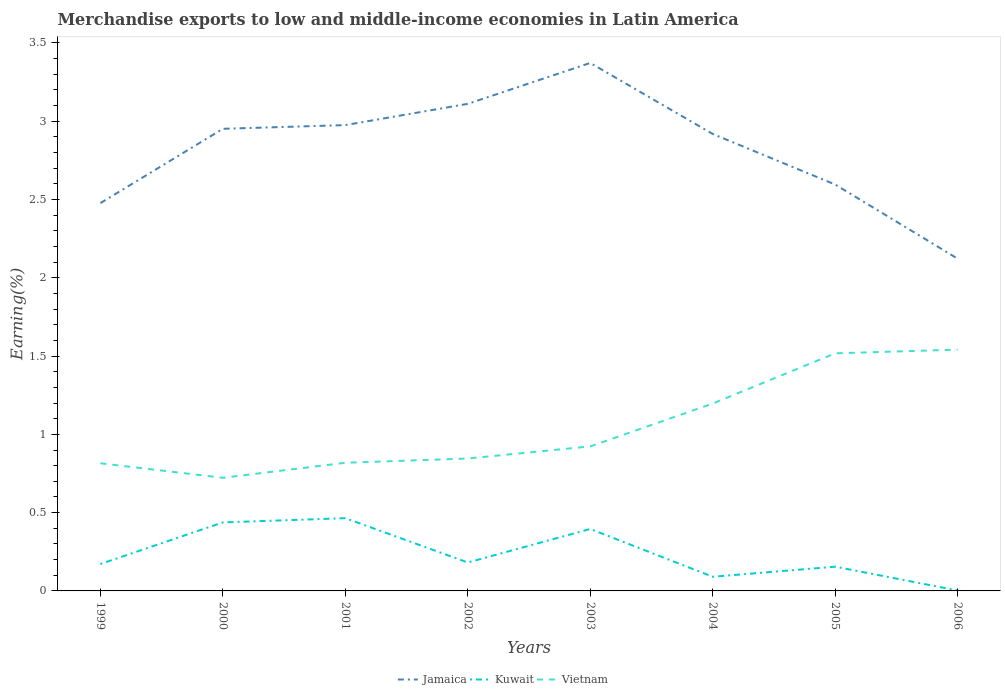Is the number of lines equal to the number of legend labels?
Provide a succinct answer. Yes. Across all years, what is the maximum percentage of amount earned from merchandise exports in Jamaica?
Offer a terse response. 2.12. In which year was the percentage of amount earned from merchandise exports in Kuwait maximum?
Your response must be concise. 2006. What is the total percentage of amount earned from merchandise exports in Kuwait in the graph?
Ensure brevity in your answer.  -0.29. What is the difference between the highest and the second highest percentage of amount earned from merchandise exports in Vietnam?
Ensure brevity in your answer.  0.82. What is the difference between two consecutive major ticks on the Y-axis?
Provide a short and direct response. 0.5. Does the graph contain grids?
Provide a short and direct response. No. How many legend labels are there?
Keep it short and to the point. 3. What is the title of the graph?
Keep it short and to the point. Merchandise exports to low and middle-income economies in Latin America. What is the label or title of the X-axis?
Offer a terse response. Years. What is the label or title of the Y-axis?
Provide a succinct answer. Earning(%). What is the Earning(%) in Jamaica in 1999?
Keep it short and to the point. 2.48. What is the Earning(%) of Kuwait in 1999?
Make the answer very short. 0.17. What is the Earning(%) of Vietnam in 1999?
Offer a very short reply. 0.82. What is the Earning(%) of Jamaica in 2000?
Your answer should be compact. 2.95. What is the Earning(%) of Kuwait in 2000?
Ensure brevity in your answer.  0.44. What is the Earning(%) in Vietnam in 2000?
Give a very brief answer. 0.72. What is the Earning(%) of Jamaica in 2001?
Offer a very short reply. 2.98. What is the Earning(%) of Kuwait in 2001?
Keep it short and to the point. 0.46. What is the Earning(%) in Vietnam in 2001?
Provide a short and direct response. 0.82. What is the Earning(%) in Jamaica in 2002?
Ensure brevity in your answer.  3.11. What is the Earning(%) of Kuwait in 2002?
Provide a succinct answer. 0.18. What is the Earning(%) in Vietnam in 2002?
Give a very brief answer. 0.85. What is the Earning(%) of Jamaica in 2003?
Your answer should be very brief. 3.37. What is the Earning(%) of Kuwait in 2003?
Your response must be concise. 0.4. What is the Earning(%) in Vietnam in 2003?
Offer a terse response. 0.92. What is the Earning(%) of Jamaica in 2004?
Your answer should be very brief. 2.92. What is the Earning(%) in Kuwait in 2004?
Ensure brevity in your answer.  0.09. What is the Earning(%) in Vietnam in 2004?
Your answer should be very brief. 1.2. What is the Earning(%) in Jamaica in 2005?
Offer a very short reply. 2.6. What is the Earning(%) of Kuwait in 2005?
Provide a succinct answer. 0.15. What is the Earning(%) of Vietnam in 2005?
Offer a terse response. 1.52. What is the Earning(%) of Jamaica in 2006?
Give a very brief answer. 2.12. What is the Earning(%) of Kuwait in 2006?
Provide a short and direct response. 0. What is the Earning(%) of Vietnam in 2006?
Provide a succinct answer. 1.54. Across all years, what is the maximum Earning(%) in Jamaica?
Provide a short and direct response. 3.37. Across all years, what is the maximum Earning(%) of Kuwait?
Make the answer very short. 0.46. Across all years, what is the maximum Earning(%) in Vietnam?
Make the answer very short. 1.54. Across all years, what is the minimum Earning(%) of Jamaica?
Your response must be concise. 2.12. Across all years, what is the minimum Earning(%) of Kuwait?
Make the answer very short. 0. Across all years, what is the minimum Earning(%) of Vietnam?
Make the answer very short. 0.72. What is the total Earning(%) in Jamaica in the graph?
Provide a short and direct response. 22.52. What is the total Earning(%) in Kuwait in the graph?
Your answer should be very brief. 1.9. What is the total Earning(%) of Vietnam in the graph?
Your response must be concise. 8.38. What is the difference between the Earning(%) in Jamaica in 1999 and that in 2000?
Provide a succinct answer. -0.47. What is the difference between the Earning(%) in Kuwait in 1999 and that in 2000?
Offer a terse response. -0.27. What is the difference between the Earning(%) of Vietnam in 1999 and that in 2000?
Provide a succinct answer. 0.09. What is the difference between the Earning(%) in Jamaica in 1999 and that in 2001?
Make the answer very short. -0.5. What is the difference between the Earning(%) in Kuwait in 1999 and that in 2001?
Give a very brief answer. -0.29. What is the difference between the Earning(%) in Vietnam in 1999 and that in 2001?
Give a very brief answer. -0. What is the difference between the Earning(%) of Jamaica in 1999 and that in 2002?
Your answer should be compact. -0.63. What is the difference between the Earning(%) in Kuwait in 1999 and that in 2002?
Offer a very short reply. -0.01. What is the difference between the Earning(%) of Vietnam in 1999 and that in 2002?
Ensure brevity in your answer.  -0.03. What is the difference between the Earning(%) in Jamaica in 1999 and that in 2003?
Give a very brief answer. -0.9. What is the difference between the Earning(%) of Kuwait in 1999 and that in 2003?
Provide a short and direct response. -0.22. What is the difference between the Earning(%) in Vietnam in 1999 and that in 2003?
Keep it short and to the point. -0.11. What is the difference between the Earning(%) in Jamaica in 1999 and that in 2004?
Provide a succinct answer. -0.44. What is the difference between the Earning(%) of Kuwait in 1999 and that in 2004?
Offer a terse response. 0.08. What is the difference between the Earning(%) in Vietnam in 1999 and that in 2004?
Provide a short and direct response. -0.38. What is the difference between the Earning(%) in Jamaica in 1999 and that in 2005?
Provide a succinct answer. -0.12. What is the difference between the Earning(%) in Kuwait in 1999 and that in 2005?
Your answer should be compact. 0.02. What is the difference between the Earning(%) of Vietnam in 1999 and that in 2005?
Provide a succinct answer. -0.7. What is the difference between the Earning(%) of Jamaica in 1999 and that in 2006?
Provide a short and direct response. 0.35. What is the difference between the Earning(%) of Kuwait in 1999 and that in 2006?
Your response must be concise. 0.17. What is the difference between the Earning(%) in Vietnam in 1999 and that in 2006?
Provide a short and direct response. -0.73. What is the difference between the Earning(%) in Jamaica in 2000 and that in 2001?
Offer a very short reply. -0.02. What is the difference between the Earning(%) of Kuwait in 2000 and that in 2001?
Provide a succinct answer. -0.03. What is the difference between the Earning(%) in Vietnam in 2000 and that in 2001?
Keep it short and to the point. -0.1. What is the difference between the Earning(%) of Jamaica in 2000 and that in 2002?
Provide a succinct answer. -0.16. What is the difference between the Earning(%) in Kuwait in 2000 and that in 2002?
Provide a succinct answer. 0.26. What is the difference between the Earning(%) of Vietnam in 2000 and that in 2002?
Provide a succinct answer. -0.12. What is the difference between the Earning(%) of Jamaica in 2000 and that in 2003?
Offer a terse response. -0.42. What is the difference between the Earning(%) in Kuwait in 2000 and that in 2003?
Give a very brief answer. 0.04. What is the difference between the Earning(%) of Vietnam in 2000 and that in 2003?
Ensure brevity in your answer.  -0.2. What is the difference between the Earning(%) in Jamaica in 2000 and that in 2004?
Your answer should be very brief. 0.03. What is the difference between the Earning(%) of Kuwait in 2000 and that in 2004?
Ensure brevity in your answer.  0.35. What is the difference between the Earning(%) of Vietnam in 2000 and that in 2004?
Provide a short and direct response. -0.47. What is the difference between the Earning(%) of Jamaica in 2000 and that in 2005?
Your answer should be compact. 0.36. What is the difference between the Earning(%) of Kuwait in 2000 and that in 2005?
Provide a succinct answer. 0.28. What is the difference between the Earning(%) of Vietnam in 2000 and that in 2005?
Your answer should be compact. -0.79. What is the difference between the Earning(%) in Jamaica in 2000 and that in 2006?
Keep it short and to the point. 0.83. What is the difference between the Earning(%) in Kuwait in 2000 and that in 2006?
Make the answer very short. 0.43. What is the difference between the Earning(%) in Vietnam in 2000 and that in 2006?
Offer a terse response. -0.82. What is the difference between the Earning(%) of Jamaica in 2001 and that in 2002?
Provide a short and direct response. -0.14. What is the difference between the Earning(%) in Kuwait in 2001 and that in 2002?
Ensure brevity in your answer.  0.28. What is the difference between the Earning(%) of Vietnam in 2001 and that in 2002?
Ensure brevity in your answer.  -0.03. What is the difference between the Earning(%) in Jamaica in 2001 and that in 2003?
Your response must be concise. -0.4. What is the difference between the Earning(%) in Kuwait in 2001 and that in 2003?
Your answer should be compact. 0.07. What is the difference between the Earning(%) in Vietnam in 2001 and that in 2003?
Your answer should be compact. -0.1. What is the difference between the Earning(%) of Jamaica in 2001 and that in 2004?
Provide a succinct answer. 0.06. What is the difference between the Earning(%) of Kuwait in 2001 and that in 2004?
Offer a terse response. 0.37. What is the difference between the Earning(%) in Vietnam in 2001 and that in 2004?
Your answer should be very brief. -0.38. What is the difference between the Earning(%) of Jamaica in 2001 and that in 2005?
Give a very brief answer. 0.38. What is the difference between the Earning(%) in Kuwait in 2001 and that in 2005?
Keep it short and to the point. 0.31. What is the difference between the Earning(%) of Vietnam in 2001 and that in 2005?
Offer a very short reply. -0.7. What is the difference between the Earning(%) of Jamaica in 2001 and that in 2006?
Give a very brief answer. 0.85. What is the difference between the Earning(%) in Kuwait in 2001 and that in 2006?
Provide a short and direct response. 0.46. What is the difference between the Earning(%) of Vietnam in 2001 and that in 2006?
Your answer should be very brief. -0.72. What is the difference between the Earning(%) in Jamaica in 2002 and that in 2003?
Offer a terse response. -0.26. What is the difference between the Earning(%) in Kuwait in 2002 and that in 2003?
Offer a very short reply. -0.21. What is the difference between the Earning(%) in Vietnam in 2002 and that in 2003?
Your response must be concise. -0.08. What is the difference between the Earning(%) in Jamaica in 2002 and that in 2004?
Your answer should be compact. 0.19. What is the difference between the Earning(%) of Kuwait in 2002 and that in 2004?
Offer a terse response. 0.09. What is the difference between the Earning(%) in Vietnam in 2002 and that in 2004?
Your response must be concise. -0.35. What is the difference between the Earning(%) of Jamaica in 2002 and that in 2005?
Your answer should be compact. 0.52. What is the difference between the Earning(%) in Kuwait in 2002 and that in 2005?
Your response must be concise. 0.03. What is the difference between the Earning(%) in Vietnam in 2002 and that in 2005?
Ensure brevity in your answer.  -0.67. What is the difference between the Earning(%) in Kuwait in 2002 and that in 2006?
Provide a succinct answer. 0.18. What is the difference between the Earning(%) in Vietnam in 2002 and that in 2006?
Offer a very short reply. -0.7. What is the difference between the Earning(%) of Jamaica in 2003 and that in 2004?
Keep it short and to the point. 0.45. What is the difference between the Earning(%) of Kuwait in 2003 and that in 2004?
Your response must be concise. 0.31. What is the difference between the Earning(%) in Vietnam in 2003 and that in 2004?
Your response must be concise. -0.27. What is the difference between the Earning(%) in Jamaica in 2003 and that in 2005?
Make the answer very short. 0.78. What is the difference between the Earning(%) of Kuwait in 2003 and that in 2005?
Ensure brevity in your answer.  0.24. What is the difference between the Earning(%) in Vietnam in 2003 and that in 2005?
Provide a short and direct response. -0.59. What is the difference between the Earning(%) in Jamaica in 2003 and that in 2006?
Your answer should be compact. 1.25. What is the difference between the Earning(%) of Kuwait in 2003 and that in 2006?
Your answer should be very brief. 0.39. What is the difference between the Earning(%) of Vietnam in 2003 and that in 2006?
Make the answer very short. -0.62. What is the difference between the Earning(%) of Jamaica in 2004 and that in 2005?
Provide a short and direct response. 0.32. What is the difference between the Earning(%) in Kuwait in 2004 and that in 2005?
Keep it short and to the point. -0.06. What is the difference between the Earning(%) of Vietnam in 2004 and that in 2005?
Make the answer very short. -0.32. What is the difference between the Earning(%) of Jamaica in 2004 and that in 2006?
Offer a terse response. 0.8. What is the difference between the Earning(%) of Kuwait in 2004 and that in 2006?
Provide a short and direct response. 0.09. What is the difference between the Earning(%) of Vietnam in 2004 and that in 2006?
Your response must be concise. -0.34. What is the difference between the Earning(%) of Jamaica in 2005 and that in 2006?
Your answer should be compact. 0.47. What is the difference between the Earning(%) in Kuwait in 2005 and that in 2006?
Your response must be concise. 0.15. What is the difference between the Earning(%) in Vietnam in 2005 and that in 2006?
Make the answer very short. -0.02. What is the difference between the Earning(%) in Jamaica in 1999 and the Earning(%) in Kuwait in 2000?
Your answer should be very brief. 2.04. What is the difference between the Earning(%) of Jamaica in 1999 and the Earning(%) of Vietnam in 2000?
Give a very brief answer. 1.75. What is the difference between the Earning(%) of Kuwait in 1999 and the Earning(%) of Vietnam in 2000?
Your answer should be compact. -0.55. What is the difference between the Earning(%) of Jamaica in 1999 and the Earning(%) of Kuwait in 2001?
Ensure brevity in your answer.  2.01. What is the difference between the Earning(%) in Jamaica in 1999 and the Earning(%) in Vietnam in 2001?
Your response must be concise. 1.66. What is the difference between the Earning(%) in Kuwait in 1999 and the Earning(%) in Vietnam in 2001?
Make the answer very short. -0.65. What is the difference between the Earning(%) of Jamaica in 1999 and the Earning(%) of Kuwait in 2002?
Offer a very short reply. 2.3. What is the difference between the Earning(%) of Jamaica in 1999 and the Earning(%) of Vietnam in 2002?
Your response must be concise. 1.63. What is the difference between the Earning(%) in Kuwait in 1999 and the Earning(%) in Vietnam in 2002?
Offer a terse response. -0.67. What is the difference between the Earning(%) in Jamaica in 1999 and the Earning(%) in Kuwait in 2003?
Make the answer very short. 2.08. What is the difference between the Earning(%) of Jamaica in 1999 and the Earning(%) of Vietnam in 2003?
Provide a succinct answer. 1.55. What is the difference between the Earning(%) in Kuwait in 1999 and the Earning(%) in Vietnam in 2003?
Keep it short and to the point. -0.75. What is the difference between the Earning(%) in Jamaica in 1999 and the Earning(%) in Kuwait in 2004?
Ensure brevity in your answer.  2.39. What is the difference between the Earning(%) in Jamaica in 1999 and the Earning(%) in Vietnam in 2004?
Make the answer very short. 1.28. What is the difference between the Earning(%) in Kuwait in 1999 and the Earning(%) in Vietnam in 2004?
Make the answer very short. -1.02. What is the difference between the Earning(%) of Jamaica in 1999 and the Earning(%) of Kuwait in 2005?
Offer a very short reply. 2.32. What is the difference between the Earning(%) of Jamaica in 1999 and the Earning(%) of Vietnam in 2005?
Give a very brief answer. 0.96. What is the difference between the Earning(%) in Kuwait in 1999 and the Earning(%) in Vietnam in 2005?
Provide a short and direct response. -1.35. What is the difference between the Earning(%) in Jamaica in 1999 and the Earning(%) in Kuwait in 2006?
Ensure brevity in your answer.  2.47. What is the difference between the Earning(%) of Jamaica in 1999 and the Earning(%) of Vietnam in 2006?
Give a very brief answer. 0.94. What is the difference between the Earning(%) in Kuwait in 1999 and the Earning(%) in Vietnam in 2006?
Give a very brief answer. -1.37. What is the difference between the Earning(%) of Jamaica in 2000 and the Earning(%) of Kuwait in 2001?
Your response must be concise. 2.49. What is the difference between the Earning(%) in Jamaica in 2000 and the Earning(%) in Vietnam in 2001?
Offer a terse response. 2.13. What is the difference between the Earning(%) of Kuwait in 2000 and the Earning(%) of Vietnam in 2001?
Give a very brief answer. -0.38. What is the difference between the Earning(%) in Jamaica in 2000 and the Earning(%) in Kuwait in 2002?
Give a very brief answer. 2.77. What is the difference between the Earning(%) of Jamaica in 2000 and the Earning(%) of Vietnam in 2002?
Offer a terse response. 2.11. What is the difference between the Earning(%) in Kuwait in 2000 and the Earning(%) in Vietnam in 2002?
Ensure brevity in your answer.  -0.41. What is the difference between the Earning(%) in Jamaica in 2000 and the Earning(%) in Kuwait in 2003?
Provide a succinct answer. 2.56. What is the difference between the Earning(%) in Jamaica in 2000 and the Earning(%) in Vietnam in 2003?
Keep it short and to the point. 2.03. What is the difference between the Earning(%) of Kuwait in 2000 and the Earning(%) of Vietnam in 2003?
Give a very brief answer. -0.49. What is the difference between the Earning(%) of Jamaica in 2000 and the Earning(%) of Kuwait in 2004?
Provide a short and direct response. 2.86. What is the difference between the Earning(%) of Jamaica in 2000 and the Earning(%) of Vietnam in 2004?
Your answer should be very brief. 1.75. What is the difference between the Earning(%) of Kuwait in 2000 and the Earning(%) of Vietnam in 2004?
Ensure brevity in your answer.  -0.76. What is the difference between the Earning(%) of Jamaica in 2000 and the Earning(%) of Kuwait in 2005?
Your answer should be compact. 2.8. What is the difference between the Earning(%) of Jamaica in 2000 and the Earning(%) of Vietnam in 2005?
Provide a succinct answer. 1.43. What is the difference between the Earning(%) in Kuwait in 2000 and the Earning(%) in Vietnam in 2005?
Make the answer very short. -1.08. What is the difference between the Earning(%) of Jamaica in 2000 and the Earning(%) of Kuwait in 2006?
Give a very brief answer. 2.95. What is the difference between the Earning(%) of Jamaica in 2000 and the Earning(%) of Vietnam in 2006?
Make the answer very short. 1.41. What is the difference between the Earning(%) of Kuwait in 2000 and the Earning(%) of Vietnam in 2006?
Provide a short and direct response. -1.1. What is the difference between the Earning(%) in Jamaica in 2001 and the Earning(%) in Kuwait in 2002?
Make the answer very short. 2.79. What is the difference between the Earning(%) of Jamaica in 2001 and the Earning(%) of Vietnam in 2002?
Give a very brief answer. 2.13. What is the difference between the Earning(%) of Kuwait in 2001 and the Earning(%) of Vietnam in 2002?
Offer a terse response. -0.38. What is the difference between the Earning(%) of Jamaica in 2001 and the Earning(%) of Kuwait in 2003?
Make the answer very short. 2.58. What is the difference between the Earning(%) of Jamaica in 2001 and the Earning(%) of Vietnam in 2003?
Make the answer very short. 2.05. What is the difference between the Earning(%) of Kuwait in 2001 and the Earning(%) of Vietnam in 2003?
Your answer should be very brief. -0.46. What is the difference between the Earning(%) in Jamaica in 2001 and the Earning(%) in Kuwait in 2004?
Your answer should be very brief. 2.88. What is the difference between the Earning(%) of Jamaica in 2001 and the Earning(%) of Vietnam in 2004?
Your response must be concise. 1.78. What is the difference between the Earning(%) in Kuwait in 2001 and the Earning(%) in Vietnam in 2004?
Ensure brevity in your answer.  -0.73. What is the difference between the Earning(%) of Jamaica in 2001 and the Earning(%) of Kuwait in 2005?
Your response must be concise. 2.82. What is the difference between the Earning(%) in Jamaica in 2001 and the Earning(%) in Vietnam in 2005?
Your answer should be compact. 1.46. What is the difference between the Earning(%) of Kuwait in 2001 and the Earning(%) of Vietnam in 2005?
Your answer should be compact. -1.05. What is the difference between the Earning(%) in Jamaica in 2001 and the Earning(%) in Kuwait in 2006?
Ensure brevity in your answer.  2.97. What is the difference between the Earning(%) in Jamaica in 2001 and the Earning(%) in Vietnam in 2006?
Provide a succinct answer. 1.43. What is the difference between the Earning(%) of Kuwait in 2001 and the Earning(%) of Vietnam in 2006?
Your response must be concise. -1.08. What is the difference between the Earning(%) of Jamaica in 2002 and the Earning(%) of Kuwait in 2003?
Make the answer very short. 2.72. What is the difference between the Earning(%) in Jamaica in 2002 and the Earning(%) in Vietnam in 2003?
Provide a succinct answer. 2.19. What is the difference between the Earning(%) of Kuwait in 2002 and the Earning(%) of Vietnam in 2003?
Offer a very short reply. -0.74. What is the difference between the Earning(%) of Jamaica in 2002 and the Earning(%) of Kuwait in 2004?
Offer a very short reply. 3.02. What is the difference between the Earning(%) in Jamaica in 2002 and the Earning(%) in Vietnam in 2004?
Keep it short and to the point. 1.91. What is the difference between the Earning(%) of Kuwait in 2002 and the Earning(%) of Vietnam in 2004?
Your answer should be very brief. -1.02. What is the difference between the Earning(%) in Jamaica in 2002 and the Earning(%) in Kuwait in 2005?
Your answer should be compact. 2.96. What is the difference between the Earning(%) in Jamaica in 2002 and the Earning(%) in Vietnam in 2005?
Make the answer very short. 1.59. What is the difference between the Earning(%) in Kuwait in 2002 and the Earning(%) in Vietnam in 2005?
Offer a terse response. -1.34. What is the difference between the Earning(%) of Jamaica in 2002 and the Earning(%) of Kuwait in 2006?
Your answer should be very brief. 3.11. What is the difference between the Earning(%) in Jamaica in 2002 and the Earning(%) in Vietnam in 2006?
Keep it short and to the point. 1.57. What is the difference between the Earning(%) of Kuwait in 2002 and the Earning(%) of Vietnam in 2006?
Offer a terse response. -1.36. What is the difference between the Earning(%) of Jamaica in 2003 and the Earning(%) of Kuwait in 2004?
Your answer should be very brief. 3.28. What is the difference between the Earning(%) of Jamaica in 2003 and the Earning(%) of Vietnam in 2004?
Your response must be concise. 2.18. What is the difference between the Earning(%) in Kuwait in 2003 and the Earning(%) in Vietnam in 2004?
Provide a succinct answer. -0.8. What is the difference between the Earning(%) of Jamaica in 2003 and the Earning(%) of Kuwait in 2005?
Offer a terse response. 3.22. What is the difference between the Earning(%) in Jamaica in 2003 and the Earning(%) in Vietnam in 2005?
Provide a short and direct response. 1.85. What is the difference between the Earning(%) in Kuwait in 2003 and the Earning(%) in Vietnam in 2005?
Provide a succinct answer. -1.12. What is the difference between the Earning(%) of Jamaica in 2003 and the Earning(%) of Kuwait in 2006?
Offer a terse response. 3.37. What is the difference between the Earning(%) in Jamaica in 2003 and the Earning(%) in Vietnam in 2006?
Offer a very short reply. 1.83. What is the difference between the Earning(%) in Kuwait in 2003 and the Earning(%) in Vietnam in 2006?
Offer a very short reply. -1.15. What is the difference between the Earning(%) in Jamaica in 2004 and the Earning(%) in Kuwait in 2005?
Provide a short and direct response. 2.76. What is the difference between the Earning(%) in Jamaica in 2004 and the Earning(%) in Vietnam in 2005?
Provide a short and direct response. 1.4. What is the difference between the Earning(%) of Kuwait in 2004 and the Earning(%) of Vietnam in 2005?
Give a very brief answer. -1.43. What is the difference between the Earning(%) of Jamaica in 2004 and the Earning(%) of Kuwait in 2006?
Provide a short and direct response. 2.92. What is the difference between the Earning(%) in Jamaica in 2004 and the Earning(%) in Vietnam in 2006?
Offer a very short reply. 1.38. What is the difference between the Earning(%) in Kuwait in 2004 and the Earning(%) in Vietnam in 2006?
Your response must be concise. -1.45. What is the difference between the Earning(%) in Jamaica in 2005 and the Earning(%) in Kuwait in 2006?
Keep it short and to the point. 2.59. What is the difference between the Earning(%) of Jamaica in 2005 and the Earning(%) of Vietnam in 2006?
Your answer should be compact. 1.05. What is the difference between the Earning(%) in Kuwait in 2005 and the Earning(%) in Vietnam in 2006?
Give a very brief answer. -1.39. What is the average Earning(%) in Jamaica per year?
Offer a terse response. 2.82. What is the average Earning(%) of Kuwait per year?
Ensure brevity in your answer.  0.24. What is the average Earning(%) in Vietnam per year?
Provide a succinct answer. 1.05. In the year 1999, what is the difference between the Earning(%) in Jamaica and Earning(%) in Kuwait?
Your answer should be very brief. 2.31. In the year 1999, what is the difference between the Earning(%) of Jamaica and Earning(%) of Vietnam?
Provide a succinct answer. 1.66. In the year 1999, what is the difference between the Earning(%) of Kuwait and Earning(%) of Vietnam?
Keep it short and to the point. -0.64. In the year 2000, what is the difference between the Earning(%) of Jamaica and Earning(%) of Kuwait?
Provide a short and direct response. 2.51. In the year 2000, what is the difference between the Earning(%) of Jamaica and Earning(%) of Vietnam?
Your answer should be very brief. 2.23. In the year 2000, what is the difference between the Earning(%) of Kuwait and Earning(%) of Vietnam?
Provide a short and direct response. -0.29. In the year 2001, what is the difference between the Earning(%) of Jamaica and Earning(%) of Kuwait?
Ensure brevity in your answer.  2.51. In the year 2001, what is the difference between the Earning(%) of Jamaica and Earning(%) of Vietnam?
Keep it short and to the point. 2.16. In the year 2001, what is the difference between the Earning(%) of Kuwait and Earning(%) of Vietnam?
Your response must be concise. -0.35. In the year 2002, what is the difference between the Earning(%) of Jamaica and Earning(%) of Kuwait?
Make the answer very short. 2.93. In the year 2002, what is the difference between the Earning(%) of Jamaica and Earning(%) of Vietnam?
Provide a short and direct response. 2.27. In the year 2002, what is the difference between the Earning(%) of Kuwait and Earning(%) of Vietnam?
Provide a succinct answer. -0.66. In the year 2003, what is the difference between the Earning(%) of Jamaica and Earning(%) of Kuwait?
Give a very brief answer. 2.98. In the year 2003, what is the difference between the Earning(%) of Jamaica and Earning(%) of Vietnam?
Your answer should be very brief. 2.45. In the year 2003, what is the difference between the Earning(%) of Kuwait and Earning(%) of Vietnam?
Ensure brevity in your answer.  -0.53. In the year 2004, what is the difference between the Earning(%) in Jamaica and Earning(%) in Kuwait?
Provide a short and direct response. 2.83. In the year 2004, what is the difference between the Earning(%) of Jamaica and Earning(%) of Vietnam?
Offer a terse response. 1.72. In the year 2004, what is the difference between the Earning(%) of Kuwait and Earning(%) of Vietnam?
Provide a succinct answer. -1.11. In the year 2005, what is the difference between the Earning(%) of Jamaica and Earning(%) of Kuwait?
Provide a succinct answer. 2.44. In the year 2005, what is the difference between the Earning(%) in Jamaica and Earning(%) in Vietnam?
Provide a succinct answer. 1.08. In the year 2005, what is the difference between the Earning(%) of Kuwait and Earning(%) of Vietnam?
Ensure brevity in your answer.  -1.36. In the year 2006, what is the difference between the Earning(%) in Jamaica and Earning(%) in Kuwait?
Your answer should be very brief. 2.12. In the year 2006, what is the difference between the Earning(%) in Jamaica and Earning(%) in Vietnam?
Make the answer very short. 0.58. In the year 2006, what is the difference between the Earning(%) in Kuwait and Earning(%) in Vietnam?
Your answer should be compact. -1.54. What is the ratio of the Earning(%) of Jamaica in 1999 to that in 2000?
Your answer should be very brief. 0.84. What is the ratio of the Earning(%) of Kuwait in 1999 to that in 2000?
Keep it short and to the point. 0.39. What is the ratio of the Earning(%) of Vietnam in 1999 to that in 2000?
Offer a terse response. 1.13. What is the ratio of the Earning(%) of Jamaica in 1999 to that in 2001?
Offer a terse response. 0.83. What is the ratio of the Earning(%) in Kuwait in 1999 to that in 2001?
Make the answer very short. 0.37. What is the ratio of the Earning(%) of Jamaica in 1999 to that in 2002?
Your answer should be very brief. 0.8. What is the ratio of the Earning(%) in Kuwait in 1999 to that in 2002?
Give a very brief answer. 0.95. What is the ratio of the Earning(%) of Vietnam in 1999 to that in 2002?
Ensure brevity in your answer.  0.96. What is the ratio of the Earning(%) of Jamaica in 1999 to that in 2003?
Offer a very short reply. 0.73. What is the ratio of the Earning(%) in Kuwait in 1999 to that in 2003?
Ensure brevity in your answer.  0.43. What is the ratio of the Earning(%) in Vietnam in 1999 to that in 2003?
Give a very brief answer. 0.88. What is the ratio of the Earning(%) of Jamaica in 1999 to that in 2004?
Offer a terse response. 0.85. What is the ratio of the Earning(%) of Kuwait in 1999 to that in 2004?
Keep it short and to the point. 1.9. What is the ratio of the Earning(%) of Vietnam in 1999 to that in 2004?
Give a very brief answer. 0.68. What is the ratio of the Earning(%) in Jamaica in 1999 to that in 2005?
Give a very brief answer. 0.95. What is the ratio of the Earning(%) in Kuwait in 1999 to that in 2005?
Offer a very short reply. 1.11. What is the ratio of the Earning(%) of Vietnam in 1999 to that in 2005?
Make the answer very short. 0.54. What is the ratio of the Earning(%) of Jamaica in 1999 to that in 2006?
Keep it short and to the point. 1.17. What is the ratio of the Earning(%) of Kuwait in 1999 to that in 2006?
Keep it short and to the point. 66.51. What is the ratio of the Earning(%) in Vietnam in 1999 to that in 2006?
Your answer should be very brief. 0.53. What is the ratio of the Earning(%) in Jamaica in 2000 to that in 2001?
Your answer should be compact. 0.99. What is the ratio of the Earning(%) of Kuwait in 2000 to that in 2001?
Your answer should be compact. 0.94. What is the ratio of the Earning(%) in Vietnam in 2000 to that in 2001?
Your answer should be compact. 0.88. What is the ratio of the Earning(%) of Jamaica in 2000 to that in 2002?
Provide a succinct answer. 0.95. What is the ratio of the Earning(%) of Kuwait in 2000 to that in 2002?
Offer a very short reply. 2.41. What is the ratio of the Earning(%) of Vietnam in 2000 to that in 2002?
Keep it short and to the point. 0.85. What is the ratio of the Earning(%) in Jamaica in 2000 to that in 2003?
Your answer should be very brief. 0.88. What is the ratio of the Earning(%) of Kuwait in 2000 to that in 2003?
Provide a succinct answer. 1.11. What is the ratio of the Earning(%) of Vietnam in 2000 to that in 2003?
Give a very brief answer. 0.78. What is the ratio of the Earning(%) of Jamaica in 2000 to that in 2004?
Offer a terse response. 1.01. What is the ratio of the Earning(%) of Kuwait in 2000 to that in 2004?
Ensure brevity in your answer.  4.84. What is the ratio of the Earning(%) of Vietnam in 2000 to that in 2004?
Make the answer very short. 0.6. What is the ratio of the Earning(%) in Jamaica in 2000 to that in 2005?
Your response must be concise. 1.14. What is the ratio of the Earning(%) in Kuwait in 2000 to that in 2005?
Your response must be concise. 2.83. What is the ratio of the Earning(%) of Vietnam in 2000 to that in 2005?
Make the answer very short. 0.48. What is the ratio of the Earning(%) of Jamaica in 2000 to that in 2006?
Keep it short and to the point. 1.39. What is the ratio of the Earning(%) in Kuwait in 2000 to that in 2006?
Make the answer very short. 169.28. What is the ratio of the Earning(%) in Vietnam in 2000 to that in 2006?
Offer a very short reply. 0.47. What is the ratio of the Earning(%) in Jamaica in 2001 to that in 2002?
Make the answer very short. 0.96. What is the ratio of the Earning(%) in Kuwait in 2001 to that in 2002?
Provide a short and direct response. 2.56. What is the ratio of the Earning(%) in Jamaica in 2001 to that in 2003?
Your answer should be compact. 0.88. What is the ratio of the Earning(%) of Kuwait in 2001 to that in 2003?
Give a very brief answer. 1.17. What is the ratio of the Earning(%) of Vietnam in 2001 to that in 2003?
Keep it short and to the point. 0.89. What is the ratio of the Earning(%) in Jamaica in 2001 to that in 2004?
Offer a very short reply. 1.02. What is the ratio of the Earning(%) of Kuwait in 2001 to that in 2004?
Your response must be concise. 5.14. What is the ratio of the Earning(%) of Vietnam in 2001 to that in 2004?
Offer a very short reply. 0.68. What is the ratio of the Earning(%) of Jamaica in 2001 to that in 2005?
Offer a terse response. 1.15. What is the ratio of the Earning(%) of Kuwait in 2001 to that in 2005?
Offer a very short reply. 3. What is the ratio of the Earning(%) in Vietnam in 2001 to that in 2005?
Ensure brevity in your answer.  0.54. What is the ratio of the Earning(%) of Jamaica in 2001 to that in 2006?
Make the answer very short. 1.4. What is the ratio of the Earning(%) in Kuwait in 2001 to that in 2006?
Make the answer very short. 179.77. What is the ratio of the Earning(%) in Vietnam in 2001 to that in 2006?
Keep it short and to the point. 0.53. What is the ratio of the Earning(%) in Jamaica in 2002 to that in 2003?
Your answer should be very brief. 0.92. What is the ratio of the Earning(%) of Kuwait in 2002 to that in 2003?
Your response must be concise. 0.46. What is the ratio of the Earning(%) in Vietnam in 2002 to that in 2003?
Give a very brief answer. 0.92. What is the ratio of the Earning(%) of Jamaica in 2002 to that in 2004?
Provide a succinct answer. 1.07. What is the ratio of the Earning(%) of Kuwait in 2002 to that in 2004?
Your response must be concise. 2.01. What is the ratio of the Earning(%) of Vietnam in 2002 to that in 2004?
Make the answer very short. 0.71. What is the ratio of the Earning(%) of Jamaica in 2002 to that in 2005?
Make the answer very short. 1.2. What is the ratio of the Earning(%) of Kuwait in 2002 to that in 2005?
Your response must be concise. 1.17. What is the ratio of the Earning(%) of Vietnam in 2002 to that in 2005?
Your response must be concise. 0.56. What is the ratio of the Earning(%) of Jamaica in 2002 to that in 2006?
Provide a succinct answer. 1.47. What is the ratio of the Earning(%) in Kuwait in 2002 to that in 2006?
Ensure brevity in your answer.  70.24. What is the ratio of the Earning(%) of Vietnam in 2002 to that in 2006?
Give a very brief answer. 0.55. What is the ratio of the Earning(%) in Jamaica in 2003 to that in 2004?
Ensure brevity in your answer.  1.16. What is the ratio of the Earning(%) in Kuwait in 2003 to that in 2004?
Your answer should be compact. 4.38. What is the ratio of the Earning(%) in Vietnam in 2003 to that in 2004?
Ensure brevity in your answer.  0.77. What is the ratio of the Earning(%) of Jamaica in 2003 to that in 2005?
Your answer should be very brief. 1.3. What is the ratio of the Earning(%) in Kuwait in 2003 to that in 2005?
Offer a very short reply. 2.56. What is the ratio of the Earning(%) in Vietnam in 2003 to that in 2005?
Your response must be concise. 0.61. What is the ratio of the Earning(%) in Jamaica in 2003 to that in 2006?
Give a very brief answer. 1.59. What is the ratio of the Earning(%) in Kuwait in 2003 to that in 2006?
Your response must be concise. 153.11. What is the ratio of the Earning(%) in Vietnam in 2003 to that in 2006?
Keep it short and to the point. 0.6. What is the ratio of the Earning(%) in Jamaica in 2004 to that in 2005?
Your answer should be compact. 1.12. What is the ratio of the Earning(%) of Kuwait in 2004 to that in 2005?
Your response must be concise. 0.58. What is the ratio of the Earning(%) of Vietnam in 2004 to that in 2005?
Give a very brief answer. 0.79. What is the ratio of the Earning(%) of Jamaica in 2004 to that in 2006?
Your response must be concise. 1.38. What is the ratio of the Earning(%) of Kuwait in 2004 to that in 2006?
Your response must be concise. 34.98. What is the ratio of the Earning(%) in Vietnam in 2004 to that in 2006?
Provide a short and direct response. 0.78. What is the ratio of the Earning(%) in Jamaica in 2005 to that in 2006?
Make the answer very short. 1.22. What is the ratio of the Earning(%) of Kuwait in 2005 to that in 2006?
Your answer should be very brief. 59.91. What is the ratio of the Earning(%) of Vietnam in 2005 to that in 2006?
Provide a short and direct response. 0.98. What is the difference between the highest and the second highest Earning(%) in Jamaica?
Keep it short and to the point. 0.26. What is the difference between the highest and the second highest Earning(%) of Kuwait?
Your answer should be compact. 0.03. What is the difference between the highest and the second highest Earning(%) of Vietnam?
Offer a very short reply. 0.02. What is the difference between the highest and the lowest Earning(%) of Jamaica?
Make the answer very short. 1.25. What is the difference between the highest and the lowest Earning(%) in Kuwait?
Offer a very short reply. 0.46. What is the difference between the highest and the lowest Earning(%) of Vietnam?
Ensure brevity in your answer.  0.82. 